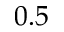Convert formula to latex. <formula><loc_0><loc_0><loc_500><loc_500>0 . 5</formula> 